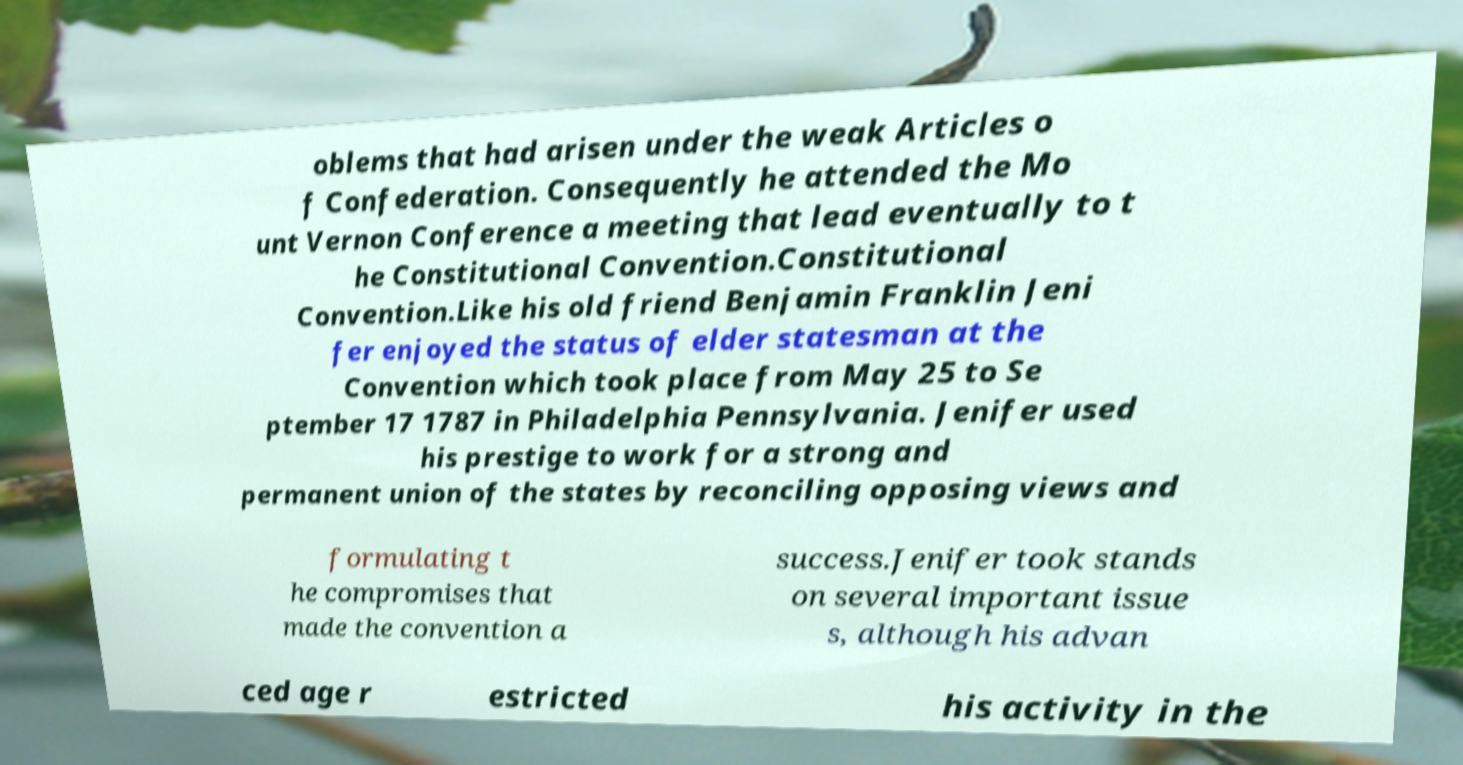Please read and relay the text visible in this image. What does it say? oblems that had arisen under the weak Articles o f Confederation. Consequently he attended the Mo unt Vernon Conference a meeting that lead eventually to t he Constitutional Convention.Constitutional Convention.Like his old friend Benjamin Franklin Jeni fer enjoyed the status of elder statesman at the Convention which took place from May 25 to Se ptember 17 1787 in Philadelphia Pennsylvania. Jenifer used his prestige to work for a strong and permanent union of the states by reconciling opposing views and formulating t he compromises that made the convention a success.Jenifer took stands on several important issue s, although his advan ced age r estricted his activity in the 